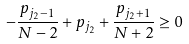Convert formula to latex. <formula><loc_0><loc_0><loc_500><loc_500>- \frac { p _ { j _ { 2 } - 1 } } { N - 2 } + p _ { j _ { 2 } } + \frac { p _ { j _ { 2 } + 1 } } { N + 2 } \geq 0</formula> 